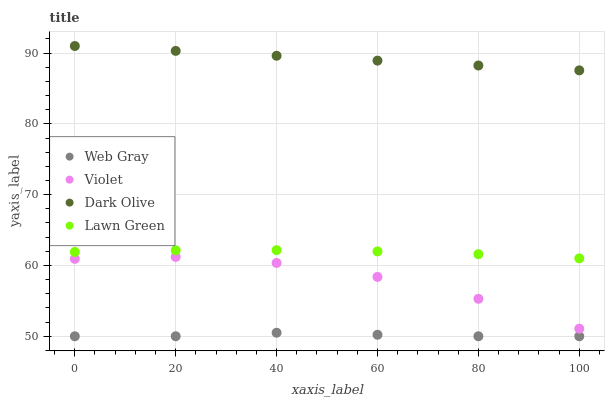Does Web Gray have the minimum area under the curve?
Answer yes or no. Yes. Does Dark Olive have the maximum area under the curve?
Answer yes or no. Yes. Does Lawn Green have the minimum area under the curve?
Answer yes or no. No. Does Lawn Green have the maximum area under the curve?
Answer yes or no. No. Is Dark Olive the smoothest?
Answer yes or no. Yes. Is Violet the roughest?
Answer yes or no. Yes. Is Lawn Green the smoothest?
Answer yes or no. No. Is Lawn Green the roughest?
Answer yes or no. No. Does Web Gray have the lowest value?
Answer yes or no. Yes. Does Lawn Green have the lowest value?
Answer yes or no. No. Does Dark Olive have the highest value?
Answer yes or no. Yes. Does Lawn Green have the highest value?
Answer yes or no. No. Is Web Gray less than Violet?
Answer yes or no. Yes. Is Lawn Green greater than Web Gray?
Answer yes or no. Yes. Does Web Gray intersect Violet?
Answer yes or no. No. 